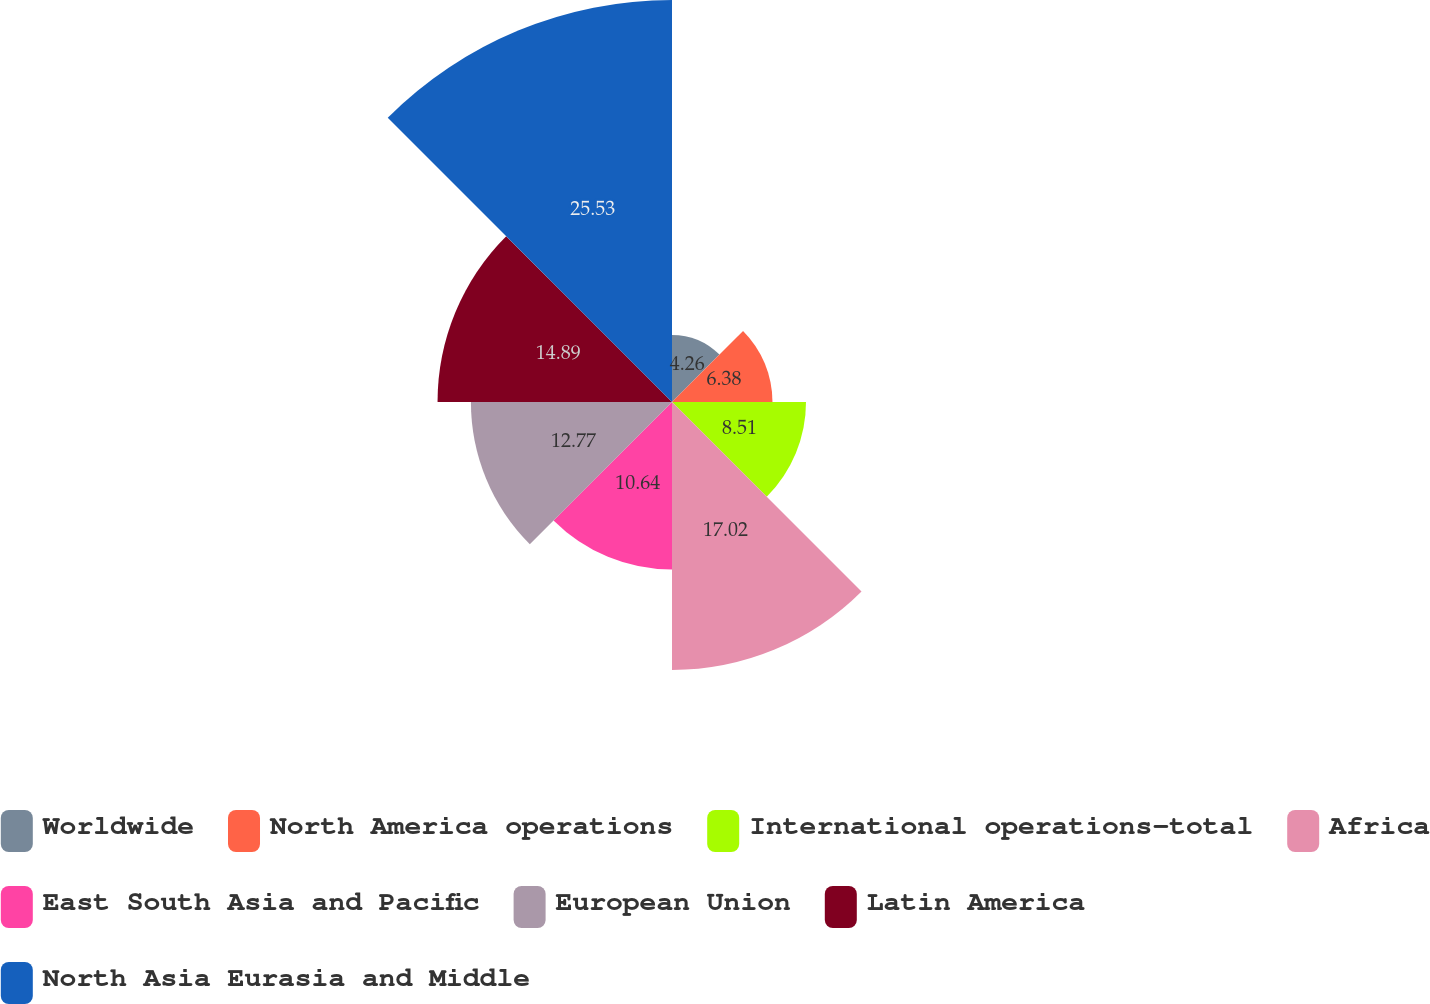Convert chart. <chart><loc_0><loc_0><loc_500><loc_500><pie_chart><fcel>Worldwide<fcel>North America operations<fcel>International operations-total<fcel>Africa<fcel>East South Asia and Pacific<fcel>European Union<fcel>Latin America<fcel>North Asia Eurasia and Middle<nl><fcel>4.26%<fcel>6.38%<fcel>8.51%<fcel>17.02%<fcel>10.64%<fcel>12.77%<fcel>14.89%<fcel>25.53%<nl></chart> 